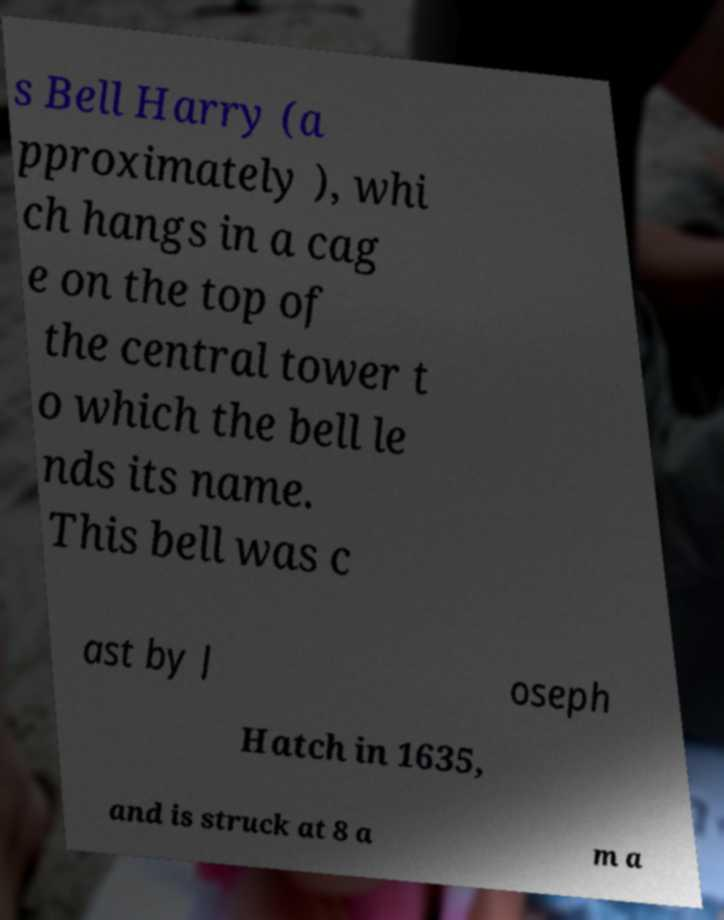What messages or text are displayed in this image? I need them in a readable, typed format. s Bell Harry (a pproximately ), whi ch hangs in a cag e on the top of the central tower t o which the bell le nds its name. This bell was c ast by J oseph Hatch in 1635, and is struck at 8 a m a 